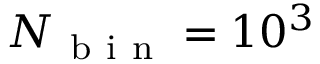<formula> <loc_0><loc_0><loc_500><loc_500>N _ { b i n } = 1 0 ^ { 3 }</formula> 